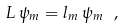<formula> <loc_0><loc_0><loc_500><loc_500>L \, \psi _ { m } = l _ { m } \, \psi _ { m } \ ,</formula> 